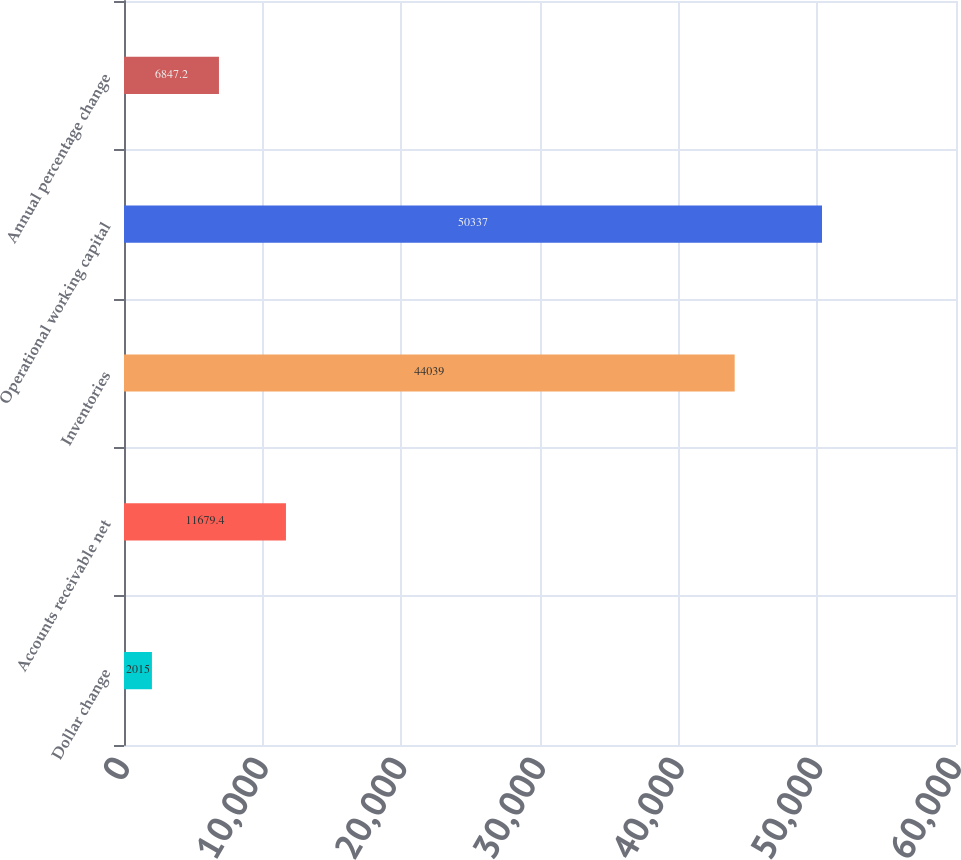<chart> <loc_0><loc_0><loc_500><loc_500><bar_chart><fcel>Dollar change<fcel>Accounts receivable net<fcel>Inventories<fcel>Operational working capital<fcel>Annual percentage change<nl><fcel>2015<fcel>11679.4<fcel>44039<fcel>50337<fcel>6847.2<nl></chart> 